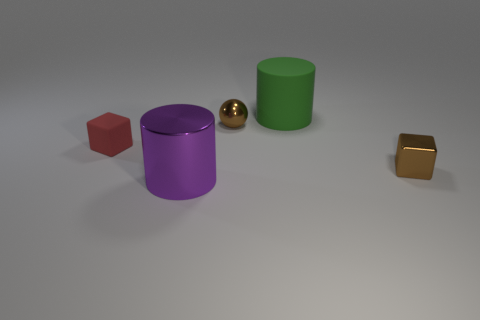What number of objects are tiny brown shiny spheres or tiny purple cylinders?
Keep it short and to the point. 1. What is the shape of the large object behind the small brown shiny thing in front of the tiny brown ball?
Offer a very short reply. Cylinder. What shape is the object that is the same material as the big green cylinder?
Your response must be concise. Cube. There is a metal object that is in front of the cube that is right of the purple metallic cylinder; what size is it?
Ensure brevity in your answer.  Large. What is the shape of the purple thing?
Ensure brevity in your answer.  Cylinder. How many small things are either red blocks or blocks?
Provide a succinct answer. 2. There is a green object that is the same shape as the large purple metallic thing; what is its size?
Your answer should be very brief. Large. What number of cylinders are behind the big metallic cylinder and to the left of the large matte object?
Your answer should be very brief. 0. There is a large green rubber thing; does it have the same shape as the rubber thing that is left of the tiny ball?
Give a very brief answer. No. Are there more tiny red matte cubes that are behind the small red cube than small red matte cubes?
Ensure brevity in your answer.  No. 